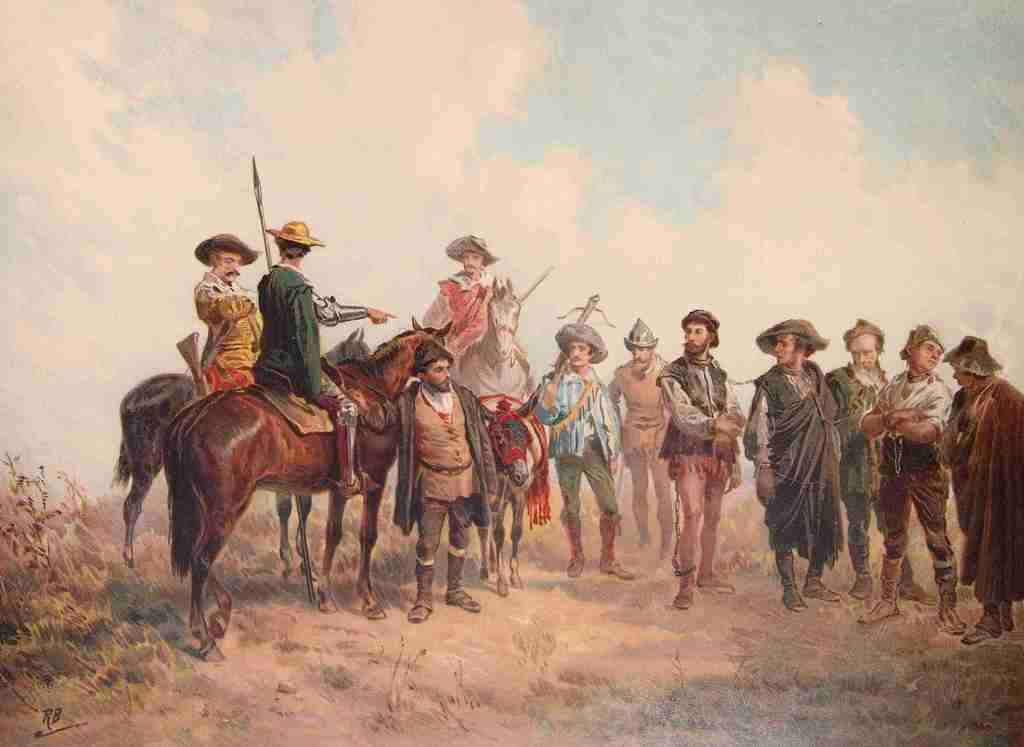What types of living beings are depicted in the painting? The painting contains people and horses. What other elements can be seen in the painting? The painting contains plants and the sky. How does the steam affect the sea in the painting? There is no steam or sea present in the painting; it contains people, horses, plants, and the sky. 